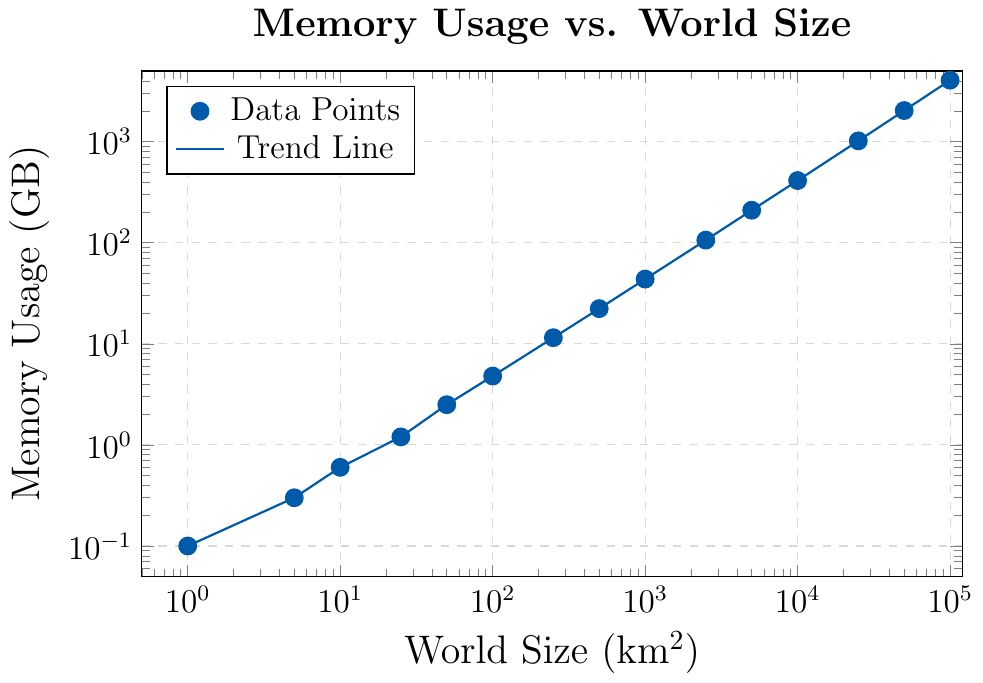What is the memory usage for a world size of 25 km²? The plot shows that at a world size of 25 km², the memory usage data is directly visible as a data point.
Answer: 1.2 GB What is the difference in memory usage between world sizes of 100 km² and 10,000 km²? Locate the data points for world sizes 100 km² and 10,000 km² on the plot. The memory usage at 100 km² is 4.8 GB and at 10,000 km² is 412.5 GB. The difference is calculated as 412.5 GB - 4.8 GB.
Answer: 407.7 GB Which world size approximately uses 1000 GB of memory? Examine the trend line and data points to identify which world size corresponds to approximately 1000 GB of memory usage. The data point at a world size of 25,000 km² shows a memory usage of 1018.3 GB, which is closest to 1000 GB.
Answer: 25,000 km² By how much does memory usage increase as world size increases from 1,000 km² to 50,000 km²? Locate the data points for world sizes 1,000 km² and 50,000 km². The memory usage at 1,000 km² is 43.7 GB and at 50,000 km² is 2031.6 GB. The increase is calculated as 2031.6 GB - 43.7 GB.
Answer: 1987.9 GB For what range of world sizes does the memory usage stay below 100 GB? Identify the data points where memory usage is below 100 GB. World sizes 1 km² (0.1 GB) to 100 km² (4.8 GB) and 250 km² (11.5 GB) are within this range. The largest world size just under 100 GB is 500 km², which has a memory usage of 22.3 GB.
Answer: 1 km² to 500 km² Is there an exponential increase in memory usage as world size increases? The plot uses a log-log scale, indicating that an exponential trend would appear linear. The trend line on the plot appears linear, which suggests an exponential increase in memory usage as world size increases.
Answer: Yes What is the average memory usage for world sizes between 1 km² and 500 km²? The data points for world sizes 1, 5, 10, 25, 50, 100, 250, and 500 km² give memory usages of 0.1, 0.3, 0.6, 1.2, 2.5, 4.8, 11.5, and 22.3 GB respectively. Sum these values and divide by the number of data points: (0.1 + 0.3 + 0.6 + 1.2 + 2.5 + 4.8 + 11.5 + 22.3) / 8.
Answer: 5.41 GB 